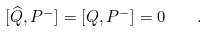Convert formula to latex. <formula><loc_0><loc_0><loc_500><loc_500>[ \widehat { Q } , P ^ { - } ] = [ Q , P ^ { - } ] = 0 \quad .</formula> 